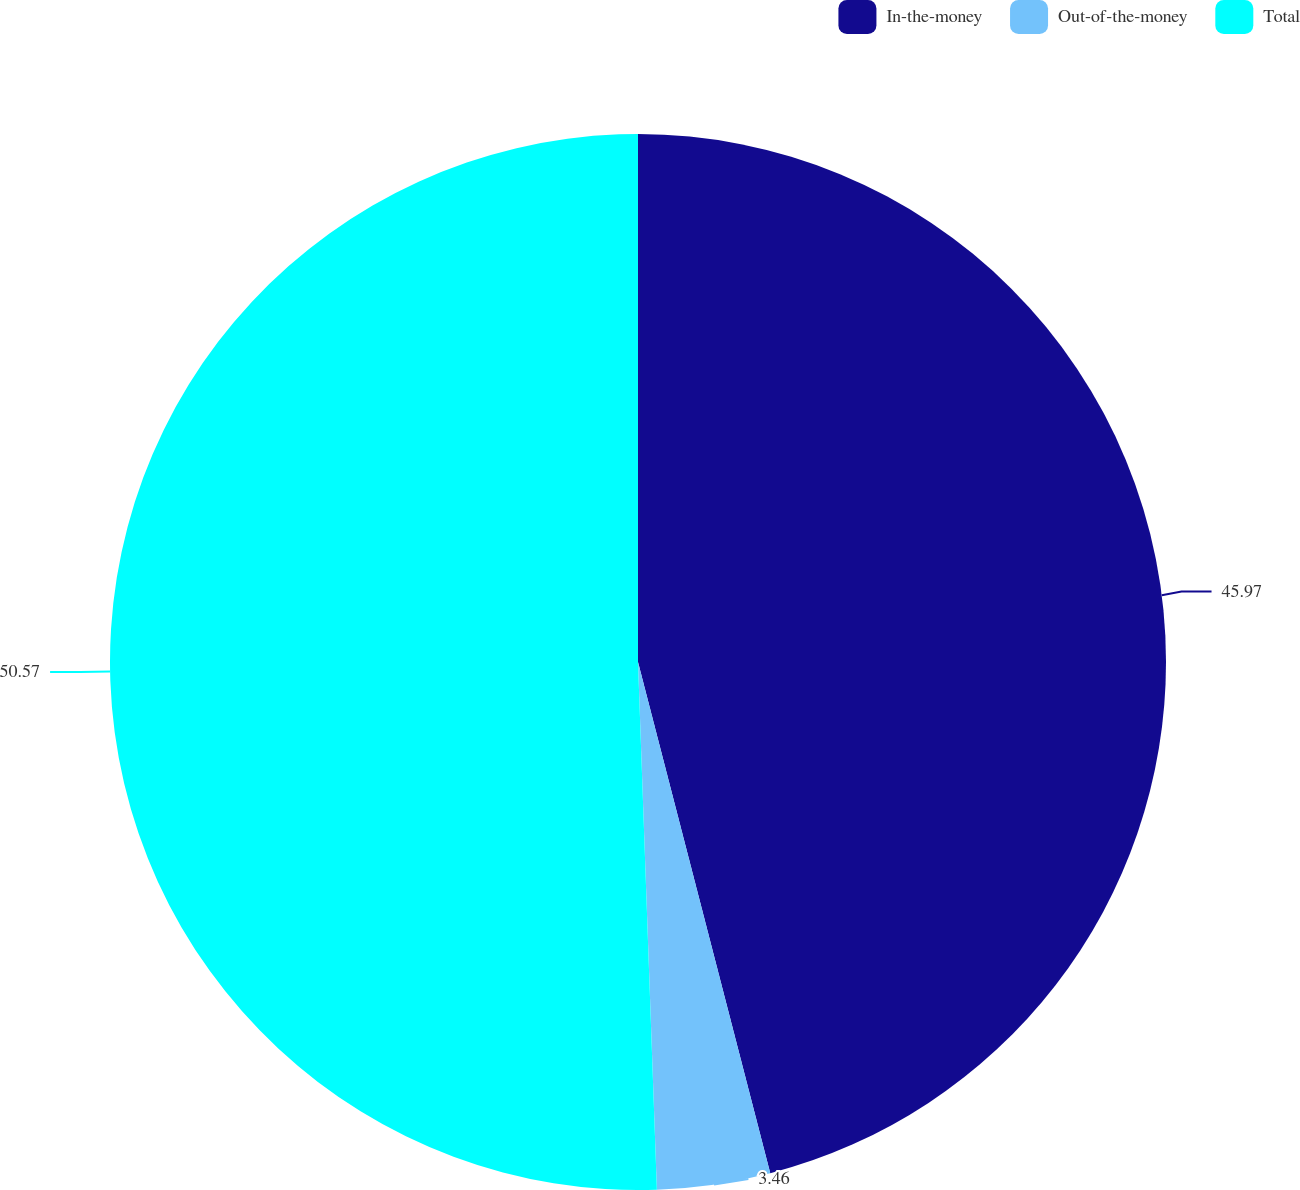Convert chart to OTSL. <chart><loc_0><loc_0><loc_500><loc_500><pie_chart><fcel>In-the-money<fcel>Out-of-the-money<fcel>Total<nl><fcel>45.97%<fcel>3.46%<fcel>50.57%<nl></chart> 